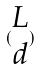<formula> <loc_0><loc_0><loc_500><loc_500>( \begin{matrix} L \\ d \end{matrix} )</formula> 